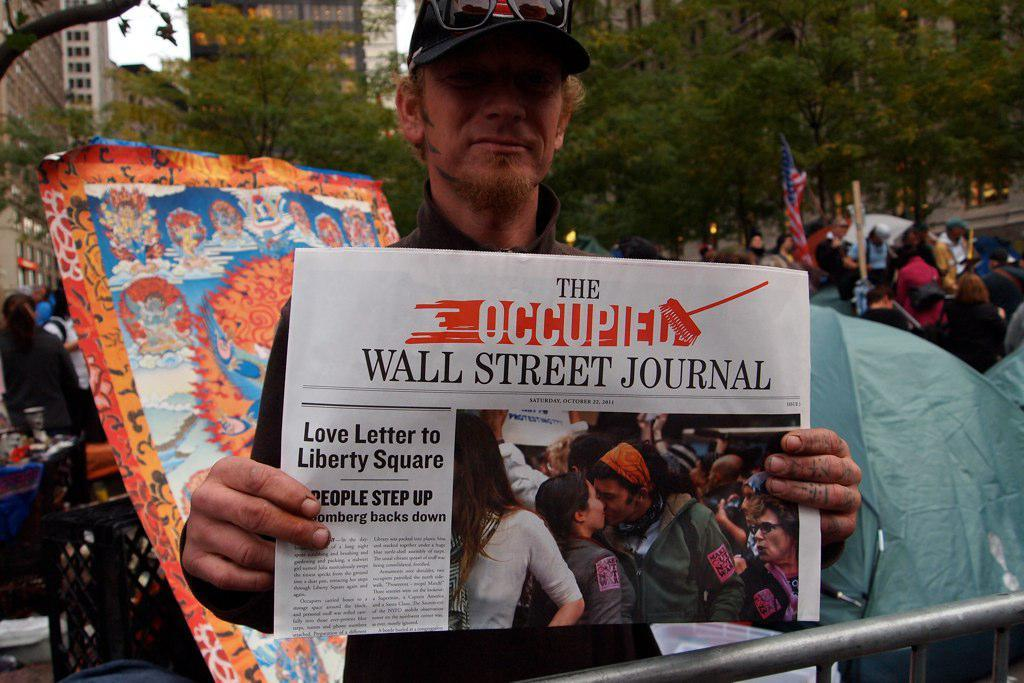Provide a one-sentence caption for the provided image. A man wearing a hat holds up a Wall Street Journal Newspaper. 